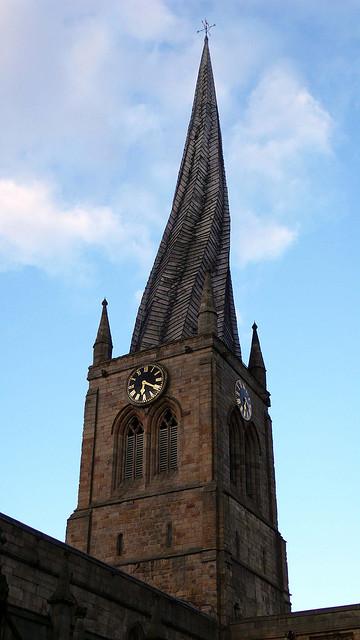What time is it?
Quick response, please. 6:20. What is on top of the steeple?
Write a very short answer. Cross. Is the sky clear?
Write a very short answer. No. Is this 5.15 PM or 5.15 AM?
Concise answer only. Pm. 